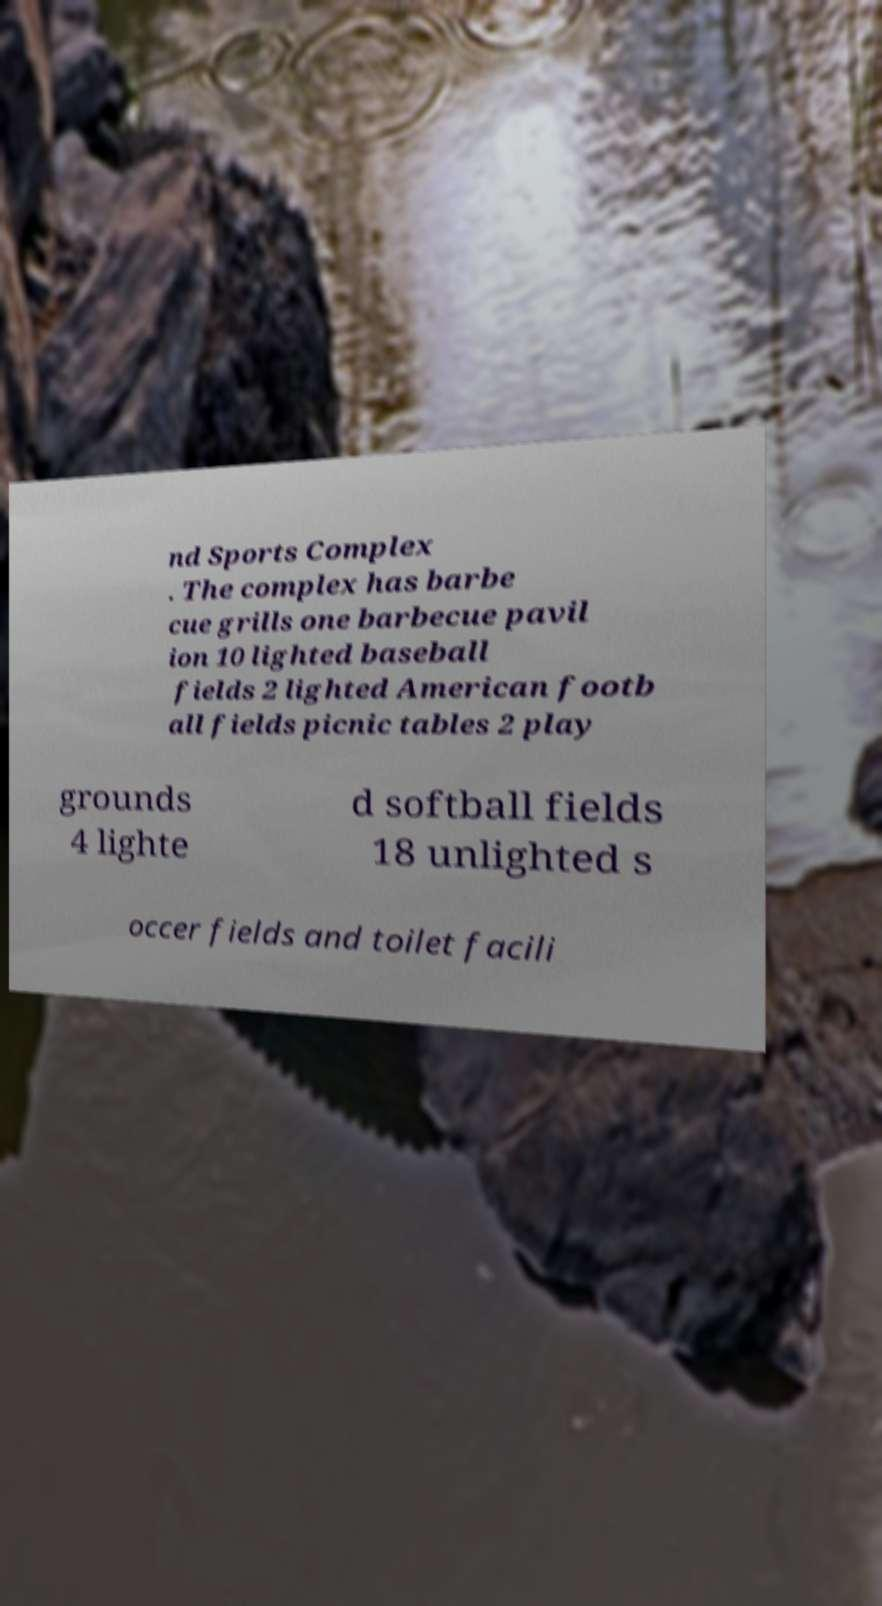Can you accurately transcribe the text from the provided image for me? nd Sports Complex . The complex has barbe cue grills one barbecue pavil ion 10 lighted baseball fields 2 lighted American footb all fields picnic tables 2 play grounds 4 lighte d softball fields 18 unlighted s occer fields and toilet facili 